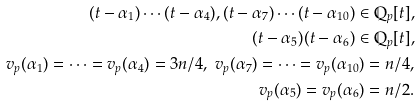<formula> <loc_0><loc_0><loc_500><loc_500>( t - \alpha _ { 1 } ) \cdots ( t - \alpha _ { 4 } ) , ( t - \alpha _ { 7 } ) \cdots ( t - \alpha _ { 1 0 } ) \in \mathbb { Q } _ { p } [ t ] , \\ ( t - \alpha _ { 5 } ) ( t - \alpha _ { 6 } ) \in \mathbb { Q } _ { p } [ t ] , \\ v _ { p } ( \alpha _ { 1 } ) = \cdots = v _ { p } ( \alpha _ { 4 } ) = 3 n / 4 , \ v _ { p } ( \alpha _ { 7 } ) = \cdots = v _ { p } ( \alpha _ { 1 0 } ) = n / 4 , \\ v _ { p } ( \alpha _ { 5 } ) = v _ { p } ( \alpha _ { 6 } ) = n / 2 .</formula> 